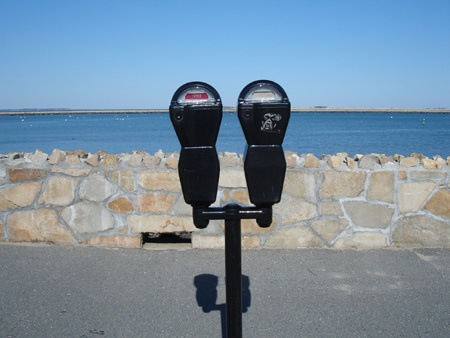Describe the objects in this image and their specific colors. I can see parking meter in gray, black, darkgray, and navy tones and parking meter in gray, black, darkgray, and navy tones in this image. 